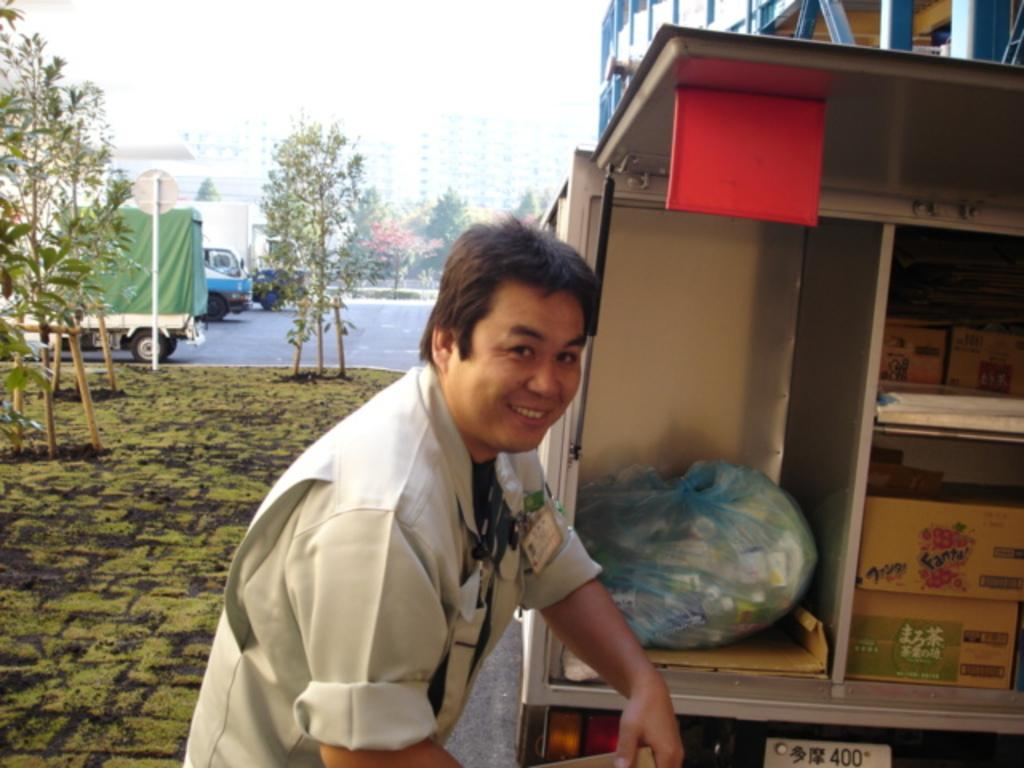What is the main subject in the image? There is a man standing in the image. What objects are present near the man? There are boxes and a cover in the image. What type of natural elements can be seen in the image? There are trees in the image. What type of man-made structures are visible in the image? Vehicles are parked in the image. What type of butter is being used to hold the rocks in the image? There is no butter or rocks present in the image. 